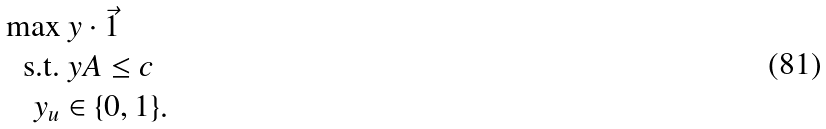Convert formula to latex. <formula><loc_0><loc_0><loc_500><loc_500>\max & \ y \cdot \vec { 1 } \\ \text {s.t.} & \ y A \leq c \\ \ y _ { u } & \in \{ 0 , 1 \} .</formula> 